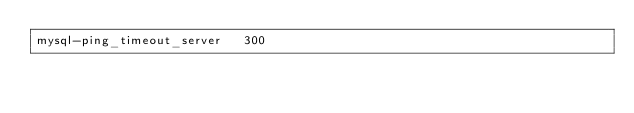Convert code to text. <code><loc_0><loc_0><loc_500><loc_500><_SQL_>mysql-ping_timeout_server	300
</code> 